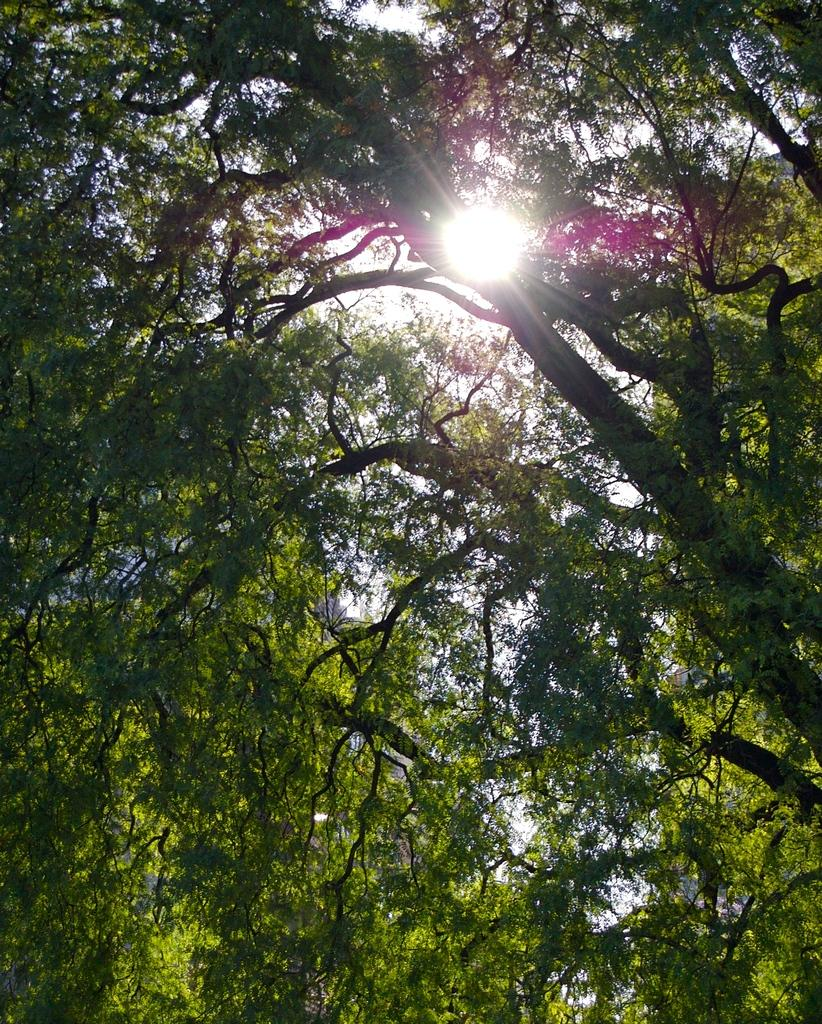What type of natural elements can be seen in the image? There are trees in the image. What is the source of light in the image? There is sunlight visible in the image. What type of curtain is blocking the sunlight in the image? There is no curtain present in the image, and the sunlight is not blocked. Can you see any guns or weapons in the image? There are no guns or weapons visible in the image. 